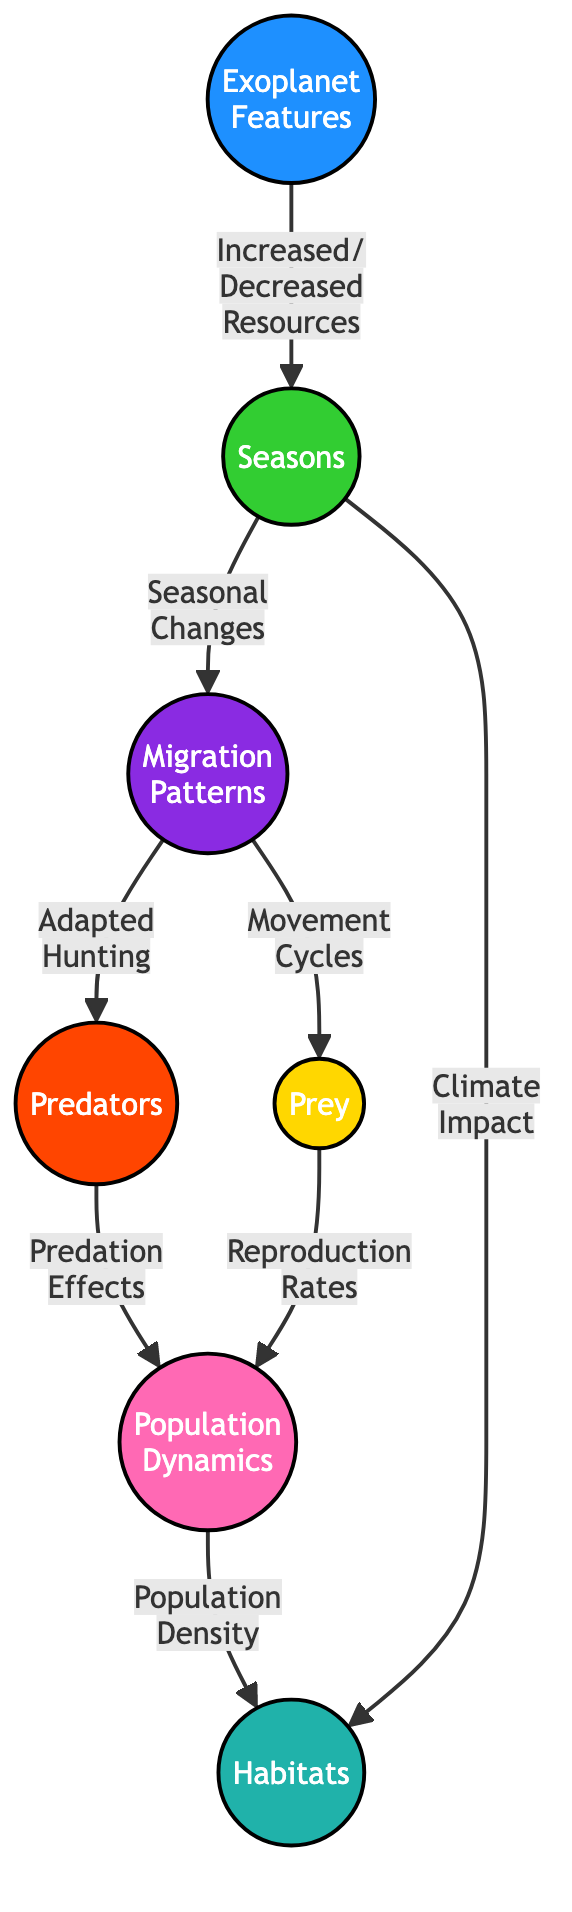What are the main factors influencing seasonal changes? The diagram indicates that increased or decreased resources are the main influencing factors on seasonal changes connected directly to the 'Seasons' node.
Answer: Increased/Decreased Resources How many nodes are related to the predator-prey dynamics? The nodes related to predator-prey dynamics include 'Predators', 'Prey', and 'Population Dynamics'. Counting these gives three nodes.
Answer: 3 What role do seasons play in migration patterns? According to the diagram, seasons are a precursor to migration patterns, indicated by the directed edge labeled 'Seasonal Changes' that leads from 'Seasons' to 'Migration Patterns'.
Answer: Seasonal Changes Which node is affected by both predation effects and reproduction rates? The 'Population Dynamics' node is impacted by both 'Predation Effects' from predators and 'Reproduction Rates' from prey, as shown by the connections in the diagram.
Answer: Population Dynamics How does the climate impact habitats? The arrow labeled 'Climate Impact' from 'Seasons' to 'Habitats' shows that climate has a direct influence on habitat conditions.
Answer: Climate Impact What is the connection between migration patterns and predators? The diagram shows that 'Migration Patterns' influence 'Predators' through the connection labeled 'Adapted Hunting', indicating a direct relationship between the two.
Answer: Adapted Hunting What happens to population density due to seasonal changes? The diagram suggests that seasonal changes, through their impact on migration patterns, ultimately affect 'Population Density', which is linked from 'Population Dynamics' to 'Habitats'.
Answer: Population Density Which node has the largest size according to the diagram? The 'Population Dynamics' node has the largest size, indicated in the style adjustments made for node dimensions.
Answer: Population Dynamics What are the main components represented in the diagram? The main components represented in the diagram include 'Planet', 'Seasons', 'Predators', 'Prey', 'Migration Patterns', 'Population Dynamics', and 'Habitats'.
Answer: 7 